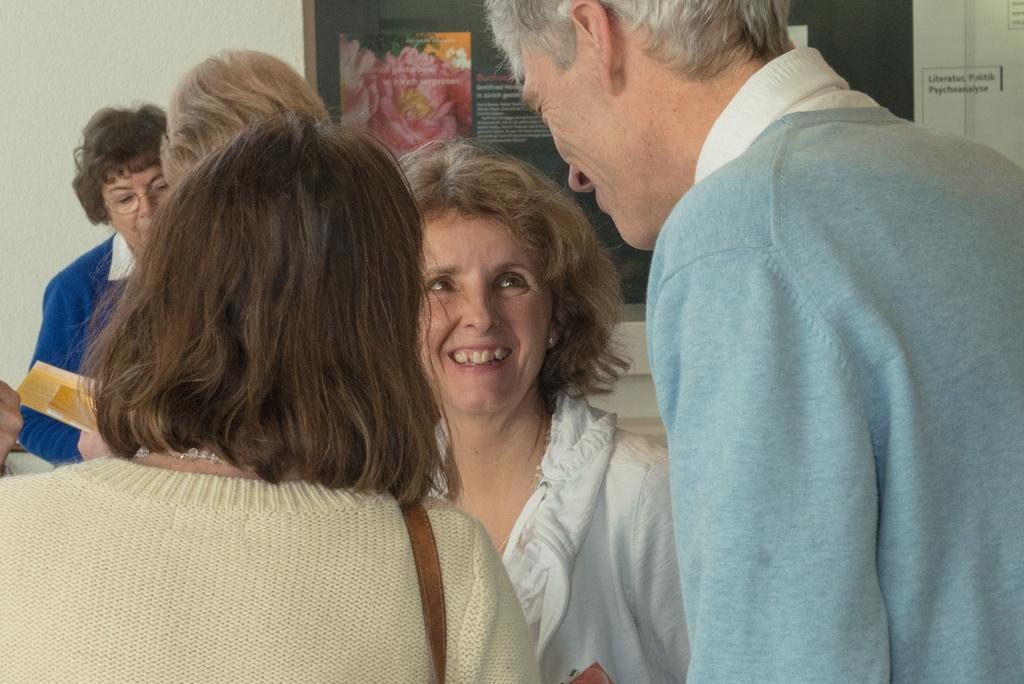What can be seen in the image? There is a group of people in the image. How are the people dressed? The people are wearing different color dresses. What is one person holding? One person is holding a yellow color paper. What is visible in the background of the image? There is a board on the wall in the background of the image. Where is the grandfather sitting in the image? There is no grandfather present in the image. What type of drain is visible in the image? There is no drain present in the image. 